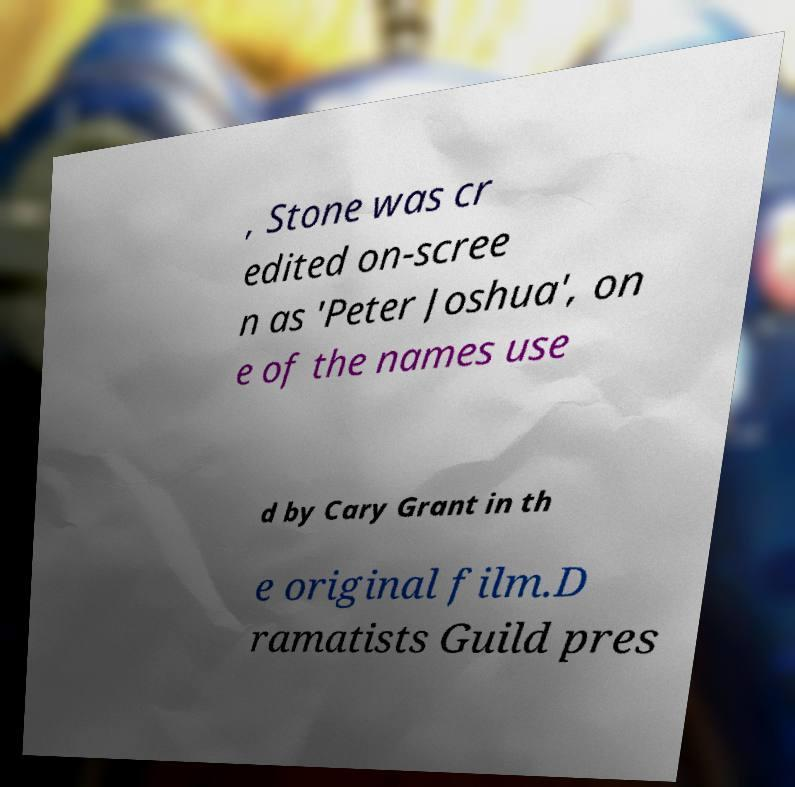Could you assist in decoding the text presented in this image and type it out clearly? , Stone was cr edited on-scree n as 'Peter Joshua', on e of the names use d by Cary Grant in th e original film.D ramatists Guild pres 